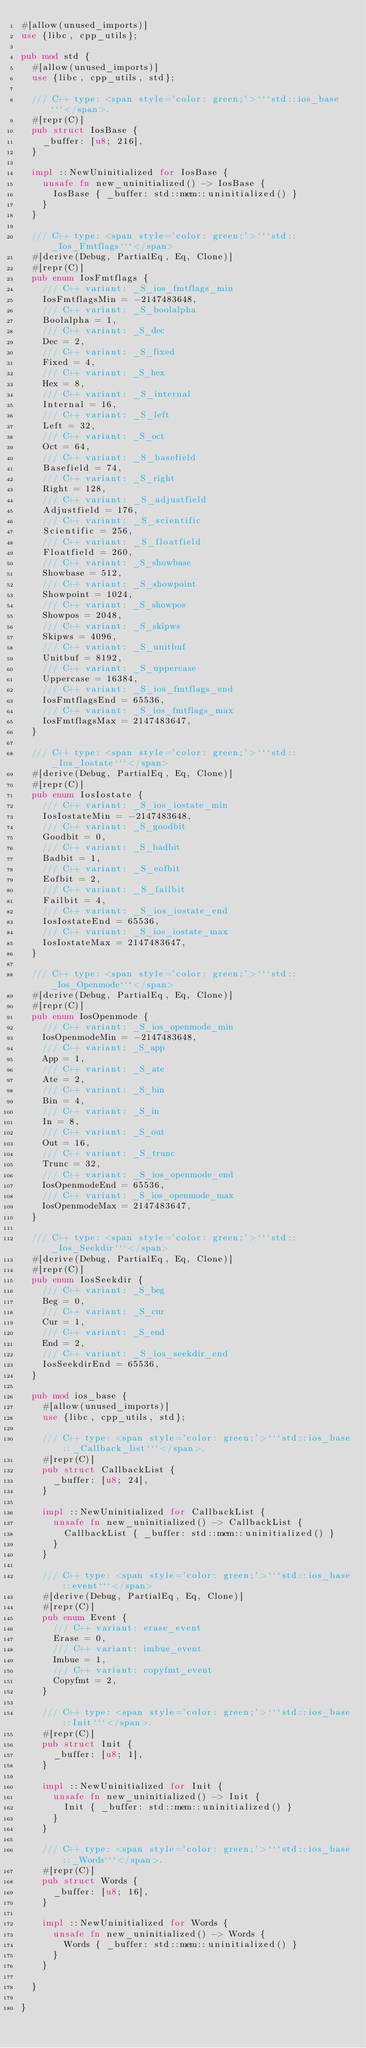<code> <loc_0><loc_0><loc_500><loc_500><_Rust_>#[allow(unused_imports)]
use {libc, cpp_utils};

pub mod std {
  #[allow(unused_imports)]
  use {libc, cpp_utils, std};

  /// C++ type: <span style='color: green;'>```std::ios_base```</span>.
  #[repr(C)]
  pub struct IosBase {
    _buffer: [u8; 216],
  }

  impl ::NewUninitialized for IosBase {
    unsafe fn new_uninitialized() -> IosBase {
      IosBase { _buffer: std::mem::uninitialized() }
    }
  }

  /// C++ type: <span style='color: green;'>```std::_Ios_Fmtflags```</span>
  #[derive(Debug, PartialEq, Eq, Clone)]
  #[repr(C)]
  pub enum IosFmtflags {
    /// C++ variant: _S_ios_fmtflags_min
    IosFmtflagsMin = -2147483648,
    /// C++ variant: _S_boolalpha
    Boolalpha = 1,
    /// C++ variant: _S_dec
    Dec = 2,
    /// C++ variant: _S_fixed
    Fixed = 4,
    /// C++ variant: _S_hex
    Hex = 8,
    /// C++ variant: _S_internal
    Internal = 16,
    /// C++ variant: _S_left
    Left = 32,
    /// C++ variant: _S_oct
    Oct = 64,
    /// C++ variant: _S_basefield
    Basefield = 74,
    /// C++ variant: _S_right
    Right = 128,
    /// C++ variant: _S_adjustfield
    Adjustfield = 176,
    /// C++ variant: _S_scientific
    Scientific = 256,
    /// C++ variant: _S_floatfield
    Floatfield = 260,
    /// C++ variant: _S_showbase
    Showbase = 512,
    /// C++ variant: _S_showpoint
    Showpoint = 1024,
    /// C++ variant: _S_showpos
    Showpos = 2048,
    /// C++ variant: _S_skipws
    Skipws = 4096,
    /// C++ variant: _S_unitbuf
    Unitbuf = 8192,
    /// C++ variant: _S_uppercase
    Uppercase = 16384,
    /// C++ variant: _S_ios_fmtflags_end
    IosFmtflagsEnd = 65536,
    /// C++ variant: _S_ios_fmtflags_max
    IosFmtflagsMax = 2147483647,
  }

  /// C++ type: <span style='color: green;'>```std::_Ios_Iostate```</span>
  #[derive(Debug, PartialEq, Eq, Clone)]
  #[repr(C)]
  pub enum IosIostate {
    /// C++ variant: _S_ios_iostate_min
    IosIostateMin = -2147483648,
    /// C++ variant: _S_goodbit
    Goodbit = 0,
    /// C++ variant: _S_badbit
    Badbit = 1,
    /// C++ variant: _S_eofbit
    Eofbit = 2,
    /// C++ variant: _S_failbit
    Failbit = 4,
    /// C++ variant: _S_ios_iostate_end
    IosIostateEnd = 65536,
    /// C++ variant: _S_ios_iostate_max
    IosIostateMax = 2147483647,
  }

  /// C++ type: <span style='color: green;'>```std::_Ios_Openmode```</span>
  #[derive(Debug, PartialEq, Eq, Clone)]
  #[repr(C)]
  pub enum IosOpenmode {
    /// C++ variant: _S_ios_openmode_min
    IosOpenmodeMin = -2147483648,
    /// C++ variant: _S_app
    App = 1,
    /// C++ variant: _S_ate
    Ate = 2,
    /// C++ variant: _S_bin
    Bin = 4,
    /// C++ variant: _S_in
    In = 8,
    /// C++ variant: _S_out
    Out = 16,
    /// C++ variant: _S_trunc
    Trunc = 32,
    /// C++ variant: _S_ios_openmode_end
    IosOpenmodeEnd = 65536,
    /// C++ variant: _S_ios_openmode_max
    IosOpenmodeMax = 2147483647,
  }

  /// C++ type: <span style='color: green;'>```std::_Ios_Seekdir```</span>
  #[derive(Debug, PartialEq, Eq, Clone)]
  #[repr(C)]
  pub enum IosSeekdir {
    /// C++ variant: _S_beg
    Beg = 0,
    /// C++ variant: _S_cur
    Cur = 1,
    /// C++ variant: _S_end
    End = 2,
    /// C++ variant: _S_ios_seekdir_end
    IosSeekdirEnd = 65536,
  }

  pub mod ios_base {
    #[allow(unused_imports)]
    use {libc, cpp_utils, std};

    /// C++ type: <span style='color: green;'>```std::ios_base::_Callback_list```</span>.
    #[repr(C)]
    pub struct CallbackList {
      _buffer: [u8; 24],
    }

    impl ::NewUninitialized for CallbackList {
      unsafe fn new_uninitialized() -> CallbackList {
        CallbackList { _buffer: std::mem::uninitialized() }
      }
    }

    /// C++ type: <span style='color: green;'>```std::ios_base::event```</span>
    #[derive(Debug, PartialEq, Eq, Clone)]
    #[repr(C)]
    pub enum Event {
      /// C++ variant: erase_event
      Erase = 0,
      /// C++ variant: imbue_event
      Imbue = 1,
      /// C++ variant: copyfmt_event
      Copyfmt = 2,
    }

    /// C++ type: <span style='color: green;'>```std::ios_base::Init```</span>.
    #[repr(C)]
    pub struct Init {
      _buffer: [u8; 1],
    }

    impl ::NewUninitialized for Init {
      unsafe fn new_uninitialized() -> Init {
        Init { _buffer: std::mem::uninitialized() }
      }
    }

    /// C++ type: <span style='color: green;'>```std::ios_base::_Words```</span>.
    #[repr(C)]
    pub struct Words {
      _buffer: [u8; 16],
    }

    impl ::NewUninitialized for Words {
      unsafe fn new_uninitialized() -> Words {
        Words { _buffer: std::mem::uninitialized() }
      }
    }

  }

}
</code> 